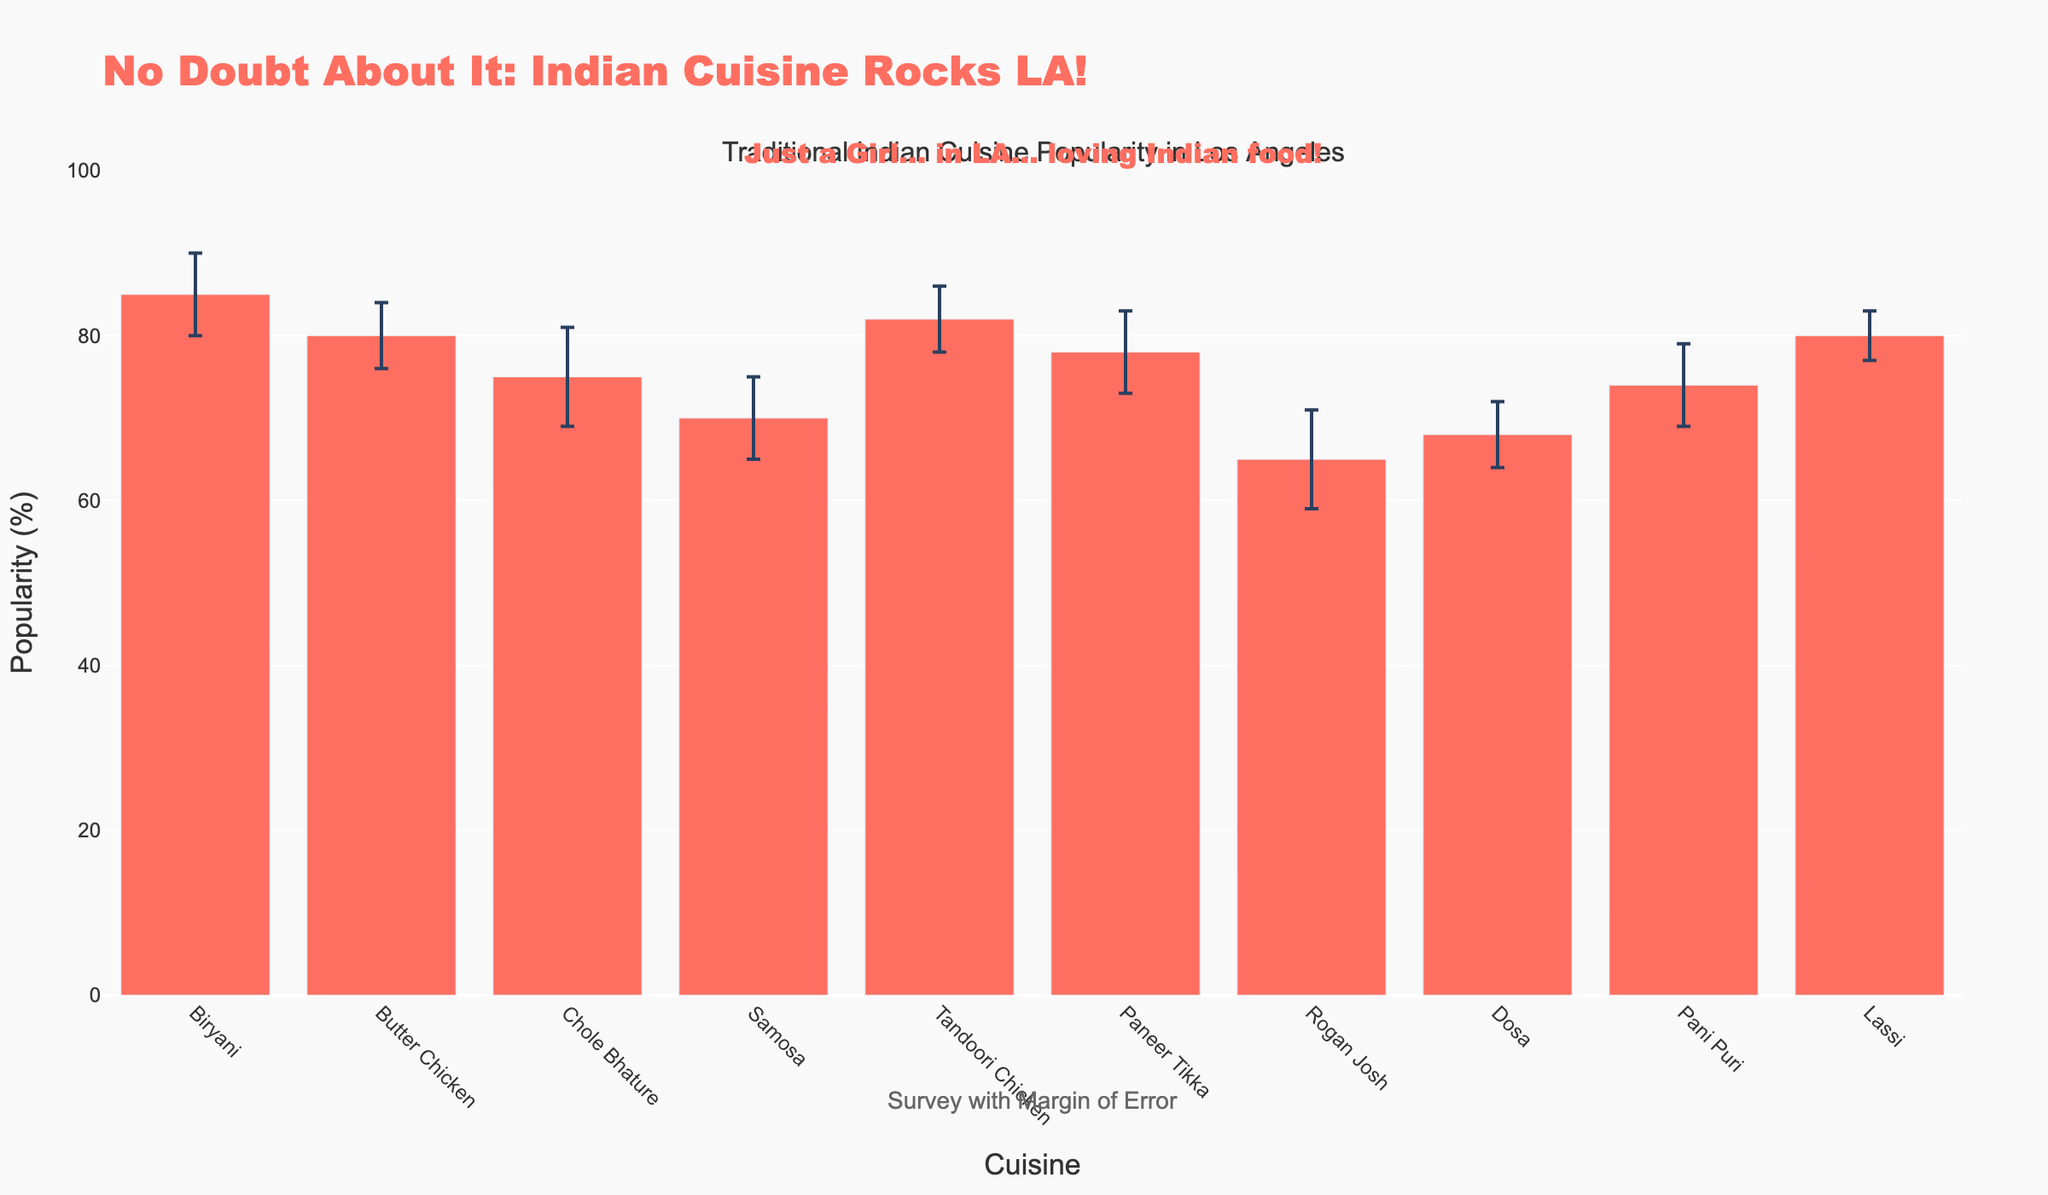What's the title of the figure? The title is usually displayed prominently at the top of the figure. In this case, the title text is "No Doubt About It: Indian Cuisine Rocks LA!".
Answer: No Doubt About It: Indian Cuisine Rocks LA! Which cuisine has the highest popularity, and what is its popularity percentage? By looking at the height of the bars on the figure, we can see that Biryani has the highest popularity. The y-axis value for Biryani is the highest at 85%.
Answer: Biryani, 85% What is the popularity difference between Butter Chicken and Paneer Tikka? The popularity of Butter Chicken is 80%, and Paneer Tikka is 78%. Subtracting these gives us the difference: 80% - 78% = 2%.
Answer: 2% Which cuisine has the widest margin of error? The margin of error is represented by the error bars. By comparing the lengths of the error bars, we can see that Chole Bhature and Rogan Josh have the widest margins of error at 6%.
Answer: Chole Bhature and Rogan Josh How many cuisines have a popularity percentage of 80% or higher? From the figure, we identify the bars with popularity percentages of 80% or more: Biryani (85%), Butter Chicken (80%), Tandoori Chicken (82%), and Lassi (80%). Counting these gives us 4 cuisines.
Answer: 4 What is the average popularity of Dosa and Pani Puri? Dosa has a popularity of 68%, and Pani Puri has 74%. Adding these and dividing by 2 gives us the average: (68 + 74) / 2 = 71%.
Answer: 71% Which cuisine has the least popularity, and what is its margin of error? By looking at the shortest bar on the figure, Rogan Josh has the least popularity at 65%. The margin of error for Rogan Josh is 6%.
Answer: Rogan Josh, 6% Comparing Samosa and Chole Bhature, which has a larger margin of error, and by how much? Samosa has a margin of error of 5%, and Chole Bhature has a margin of error of 6%. The difference is 6% - 5% = 1%.
Answer: Chole Bhature, 1% What does the annotation at the bottom with text "Survey with Margin of Error" signify? This annotation likely indicates that the figure illustrates data collected from a survey and that each point includes a margin of error, reflecting the uncertainty or variability in the survey results.
Answer: Reflects survey data with margin of error What humorous annotation has been added to the figure as a "No Doubt-inspired touch"? The figure includes a humorous annotation at the top with the text "Just a Girl... in LA... loving Indian food!". This adds a personal and casual touch.
Answer: Just a Girl... in LA... loving Indian food! 